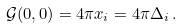Convert formula to latex. <formula><loc_0><loc_0><loc_500><loc_500>\mathcal { G } ( 0 , 0 ) = 4 \pi x _ { i } = 4 \pi \Delta _ { i } \, .</formula> 